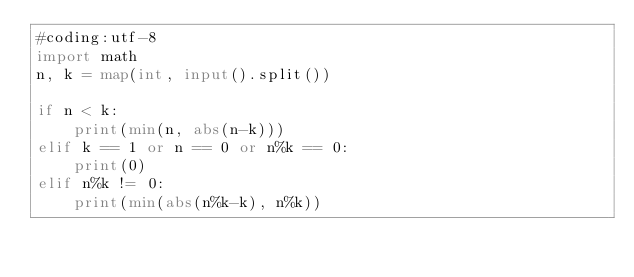Convert code to text. <code><loc_0><loc_0><loc_500><loc_500><_Python_>#coding:utf-8
import math
n, k = map(int, input().split())

if n < k:
    print(min(n, abs(n-k)))
elif k == 1 or n == 0 or n%k == 0:
    print(0)
elif n%k != 0:
    print(min(abs(n%k-k), n%k))
</code> 